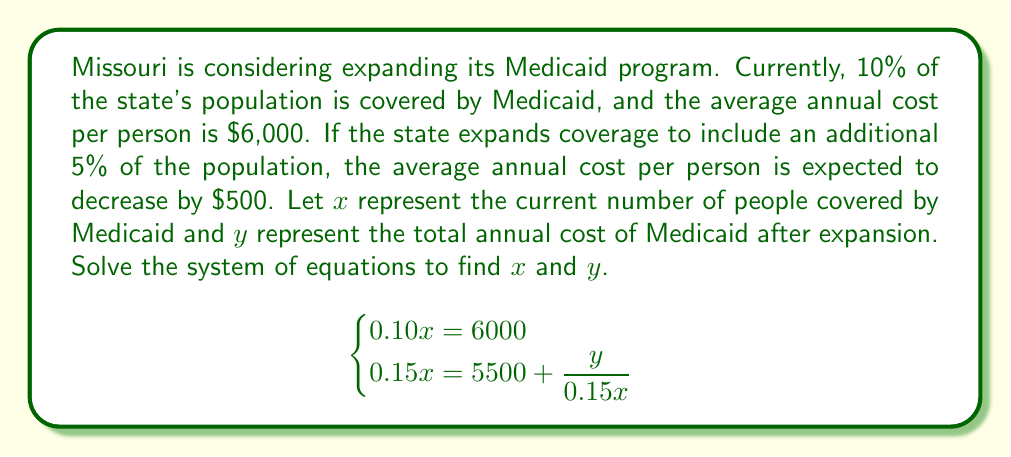Solve this math problem. Let's solve this system of equations step by step:

1) From the first equation: $0.10x = 6000$
   Solving for $x$:
   $x = 6000 \div 0.10 = 60,000$

2) Now that we know $x$, let's substitute it into the second equation:
   $0.15(60,000) = 5500 + \frac{y}{0.15(60,000)}$

3) Simplify:
   $9000 = 5500 + \frac{y}{9000}$

4) Subtract 5500 from both sides:
   $3500 = \frac{y}{9000}$

5) Multiply both sides by 9000:
   $3500 \cdot 9000 = y$
   $y = 31,500,000$

6) Therefore, $x = 60,000$ and $y = 31,500,000$

To verify:
- 10% of 60,000 is indeed 6,000 people (current coverage)
- 15% of 60,000 is 9,000 people (expanded coverage)
- $31,500,000 \div 9000 = 3500$ per person (new average cost)
- $3500 + 500 = 4000$ (original average cost)
- $4000 \cdot 1.5 = 6000$ (original total cost per person)

This solution shows that expanding Medicaid would cover an additional 3,000 people while reducing the average cost per person by $500, resulting in a total annual cost of $31.5 million.
Answer: $x = 60,000$, $y = 31,500,000$ 